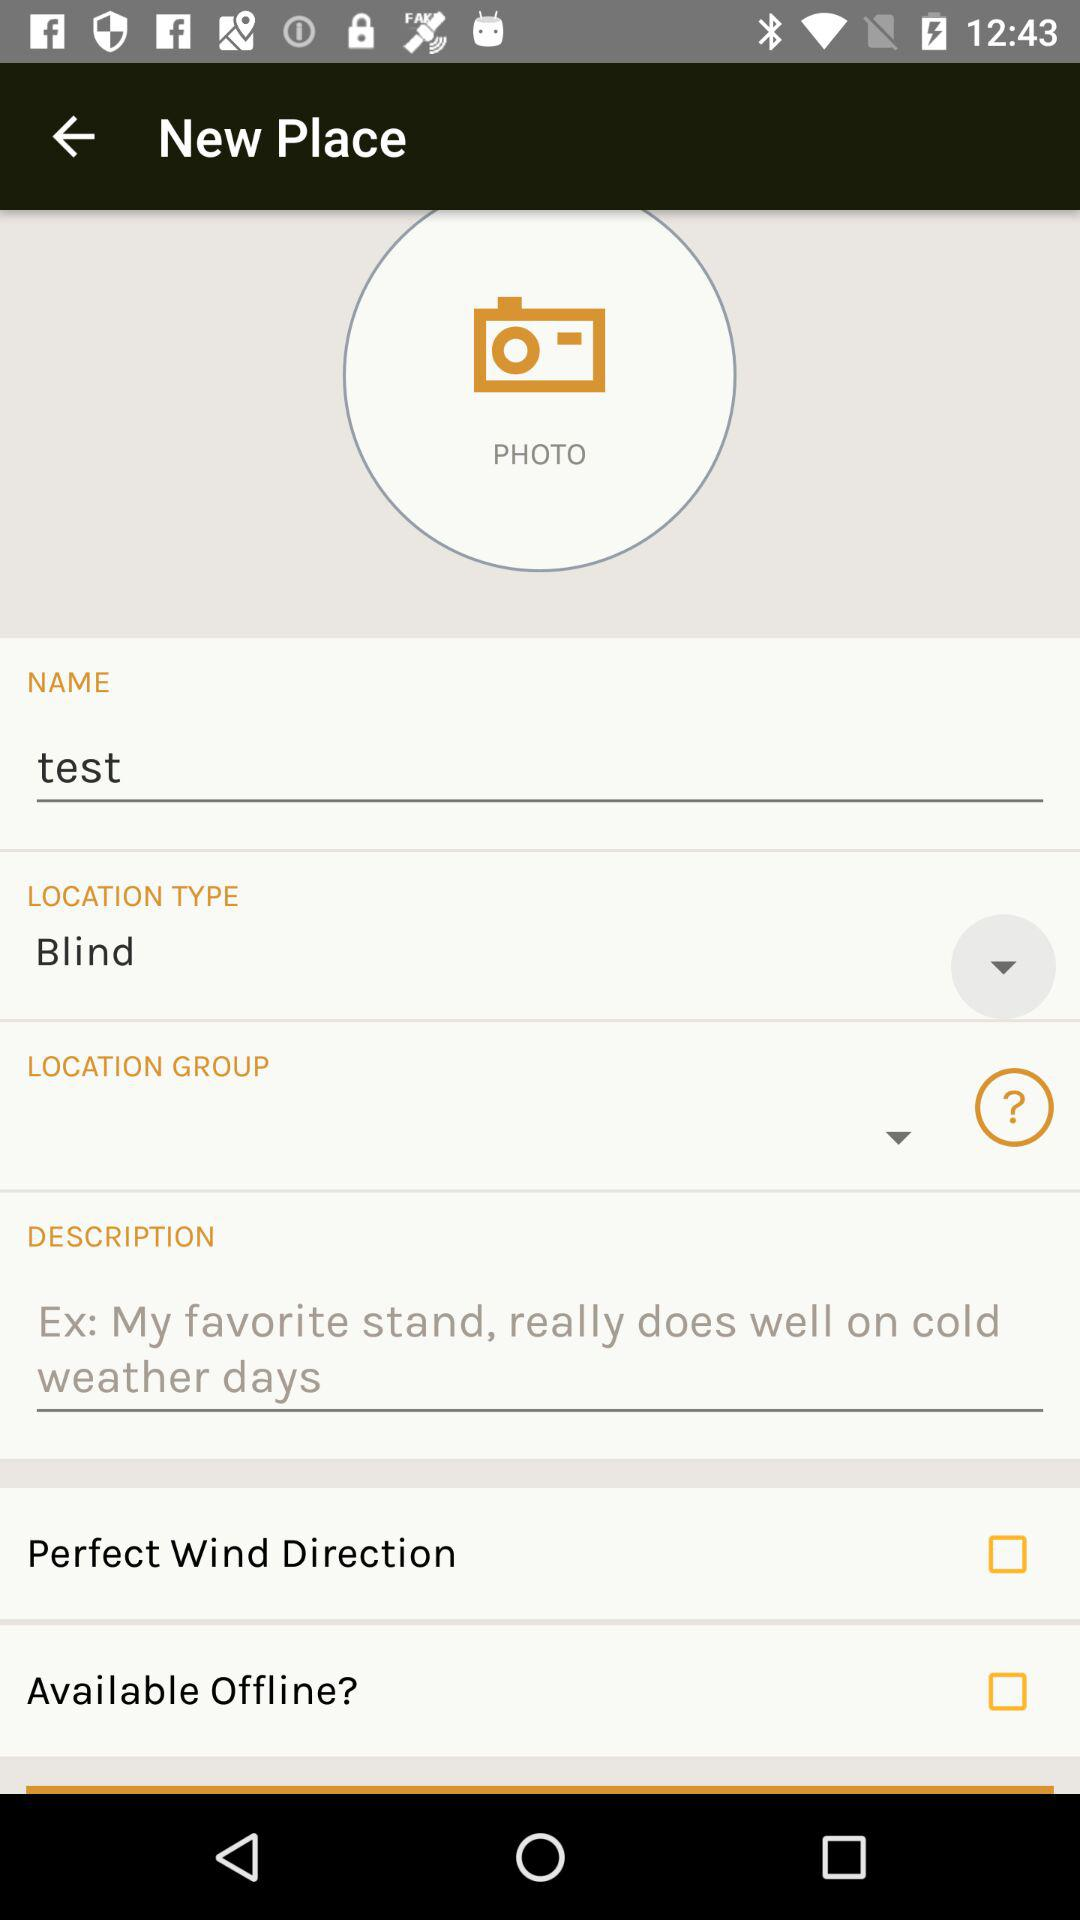What is the status of the "Perfect Wind Direction"? The status of the "Perfect Wind Direction" is "off". 